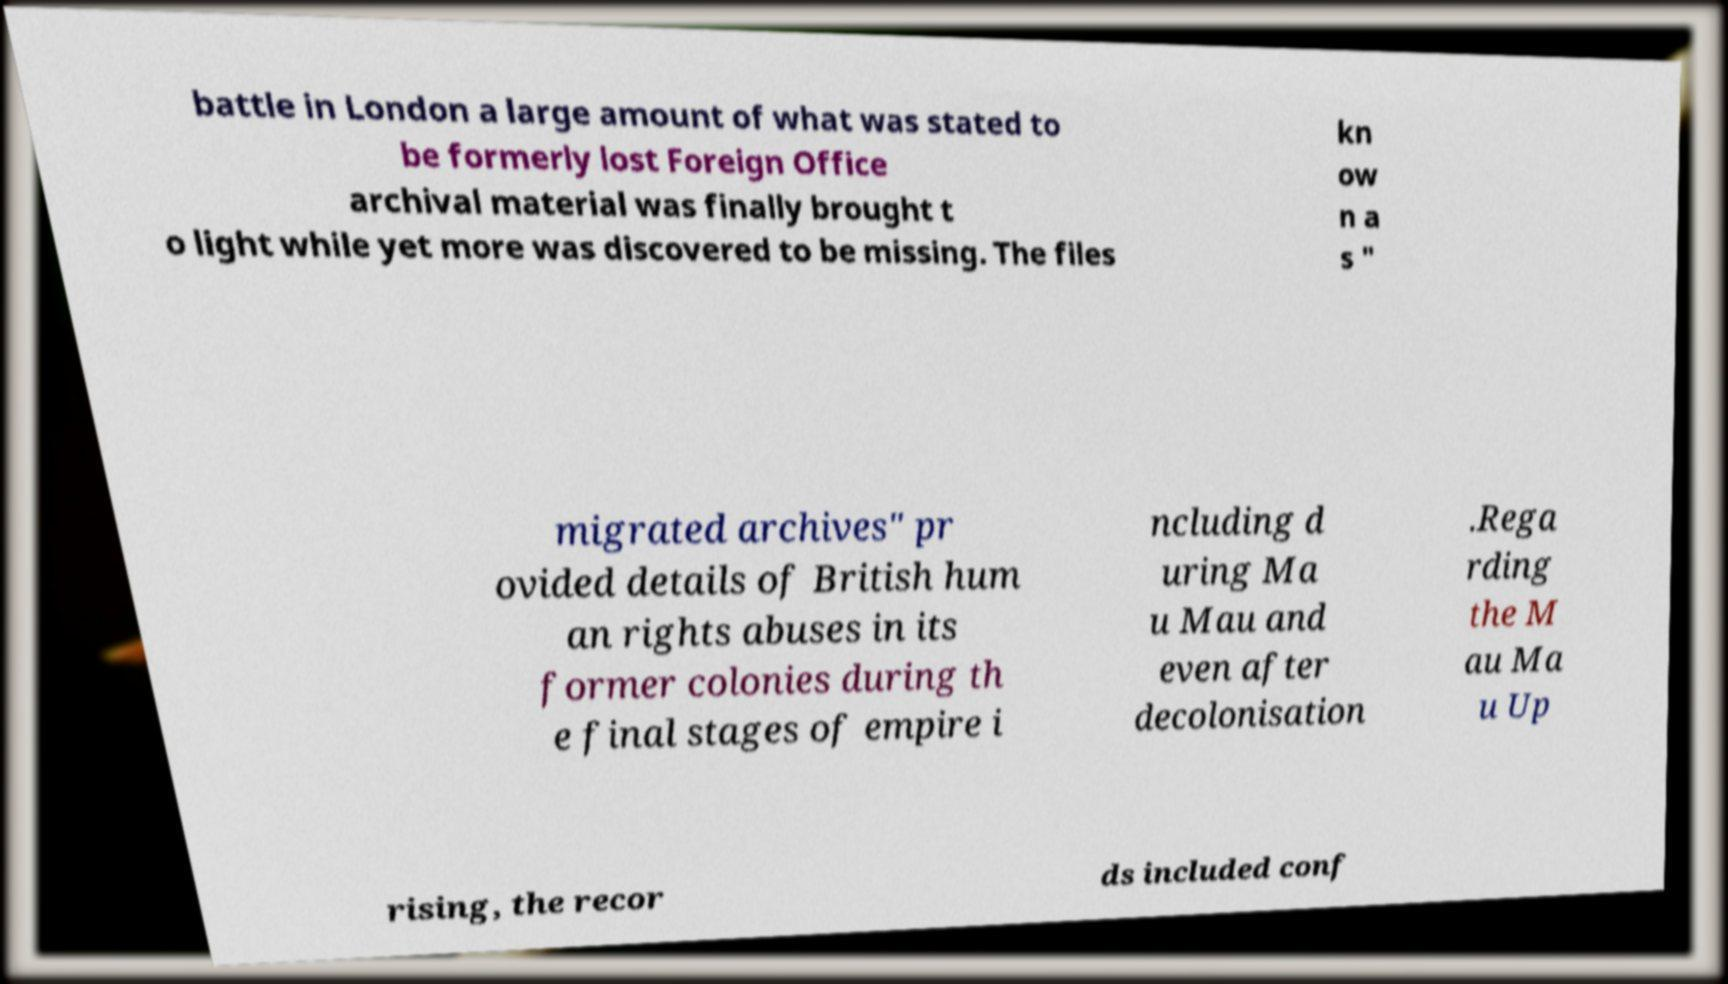There's text embedded in this image that I need extracted. Can you transcribe it verbatim? battle in London a large amount of what was stated to be formerly lost Foreign Office archival material was finally brought t o light while yet more was discovered to be missing. The files kn ow n a s " migrated archives" pr ovided details of British hum an rights abuses in its former colonies during th e final stages of empire i ncluding d uring Ma u Mau and even after decolonisation .Rega rding the M au Ma u Up rising, the recor ds included conf 